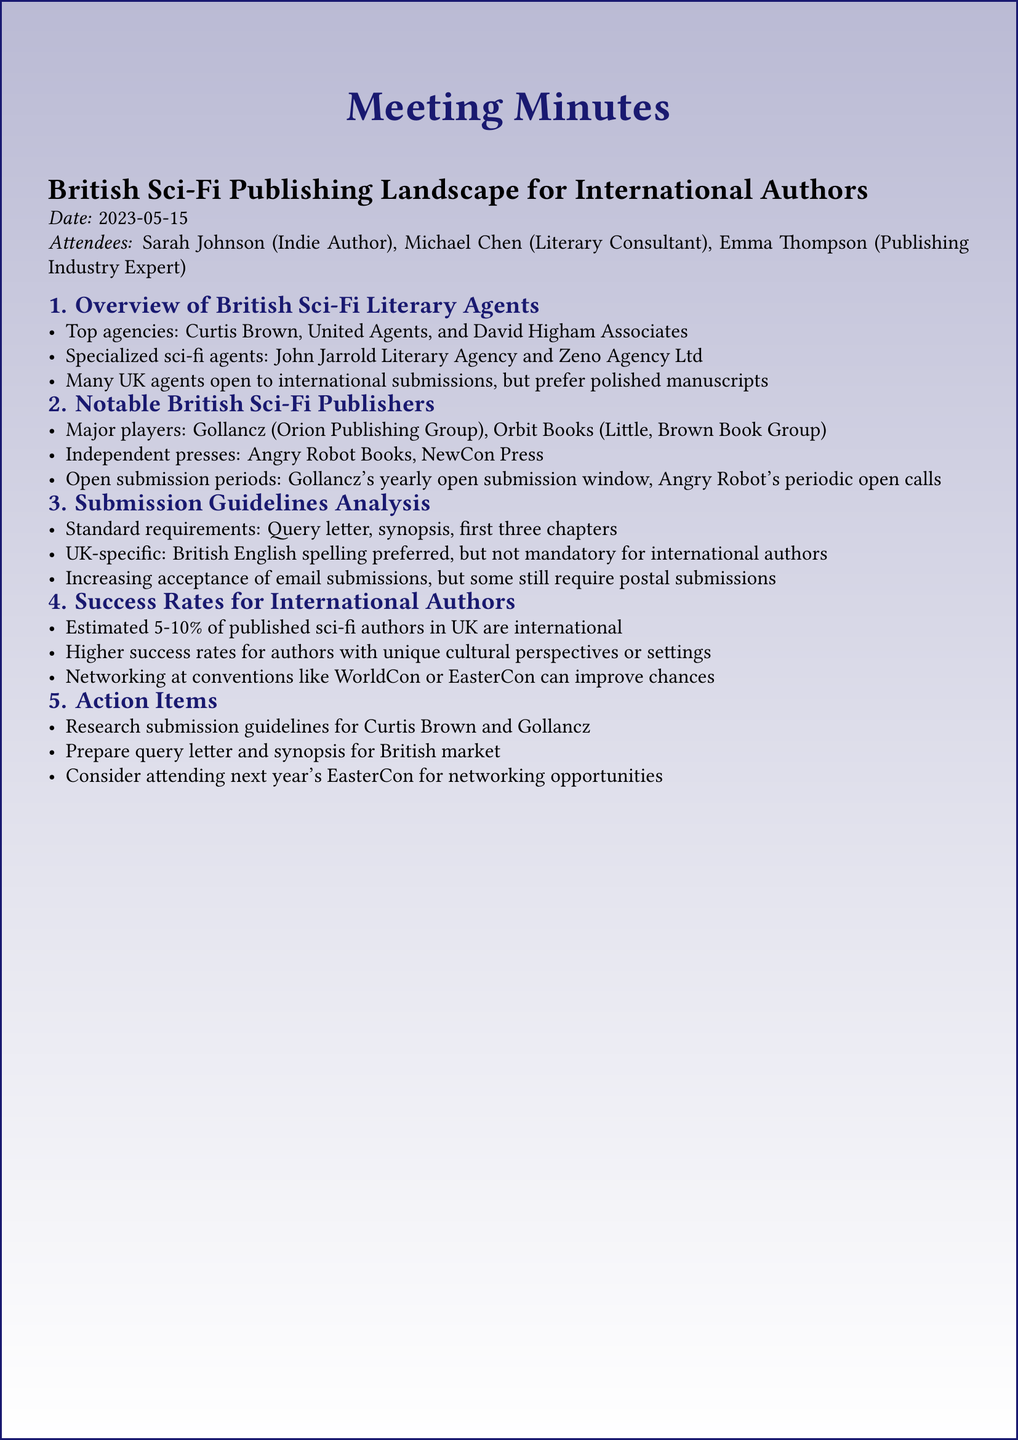What are the top agencies mentioned? The document lists the top agencies for British sci-fi literary representation, which are Curtis Brown, United Agents, and David Higham Associates.
Answer: Curtis Brown, United Agents, David Higham Associates Which independent presses are highlighted? The document specifies notable independent presses in British sci-fi publishing, namely Angry Robot Books and NewCon Press.
Answer: Angry Robot Books, NewCon Press What are the submission requirements? The document outlines the standard requirements for submissions, including a query letter, synopsis, and the first three chapters.
Answer: Query letter, synopsis, first three chapters What is the estimated percentage of international authors published in the UK? The document provides an estimate on the representation of international authors, saying that 5-10% of published sci-fi authors in the UK are international.
Answer: 5-10% What does the document recommend for improving publishing chances? The discussion includes the importance of networking at conventions like WorldCon or EasterCon to enhance the chances of success for international authors.
Answer: Networking at conventions What action item pertains to the submission guidelines for Curtis Brown? An action item in the minutes states the need to research submission guidelines specifically for Curtis Brown.
Answer: Research submission guidelines for Curtis Brown What is preferred regarding spelling for submissions? The document notes that British English spelling is preferred for submissions, though not mandatory for international authors.
Answer: British English spelling preferred Which open submission window is mentioned? The document refers to Gollancz's yearly open submission window as an important opportunity for authors.
Answer: Gollancz's yearly open submission window 